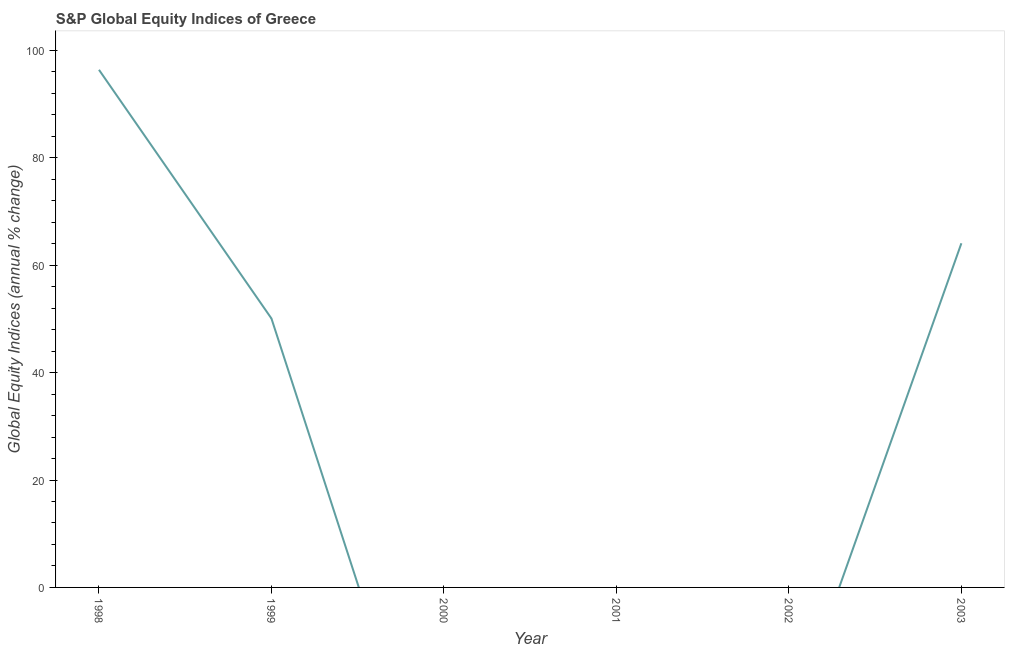What is the s&p global equity indices in 1999?
Give a very brief answer. 50.08. Across all years, what is the maximum s&p global equity indices?
Make the answer very short. 96.39. In which year was the s&p global equity indices maximum?
Offer a terse response. 1998. What is the sum of the s&p global equity indices?
Make the answer very short. 210.56. What is the difference between the s&p global equity indices in 1998 and 2003?
Your answer should be very brief. 32.3. What is the average s&p global equity indices per year?
Your answer should be very brief. 35.09. What is the median s&p global equity indices?
Your answer should be very brief. 25.04. What is the difference between the highest and the second highest s&p global equity indices?
Keep it short and to the point. 32.3. Is the sum of the s&p global equity indices in 1998 and 1999 greater than the maximum s&p global equity indices across all years?
Provide a short and direct response. Yes. What is the difference between the highest and the lowest s&p global equity indices?
Ensure brevity in your answer.  96.39. Does the s&p global equity indices monotonically increase over the years?
Your response must be concise. No. What is the difference between two consecutive major ticks on the Y-axis?
Ensure brevity in your answer.  20. Does the graph contain any zero values?
Offer a very short reply. Yes. What is the title of the graph?
Offer a very short reply. S&P Global Equity Indices of Greece. What is the label or title of the Y-axis?
Offer a very short reply. Global Equity Indices (annual % change). What is the Global Equity Indices (annual % change) in 1998?
Ensure brevity in your answer.  96.39. What is the Global Equity Indices (annual % change) of 1999?
Offer a very short reply. 50.08. What is the Global Equity Indices (annual % change) in 2003?
Your response must be concise. 64.09. What is the difference between the Global Equity Indices (annual % change) in 1998 and 1999?
Your response must be concise. 46.31. What is the difference between the Global Equity Indices (annual % change) in 1998 and 2003?
Your response must be concise. 32.3. What is the difference between the Global Equity Indices (annual % change) in 1999 and 2003?
Make the answer very short. -14.01. What is the ratio of the Global Equity Indices (annual % change) in 1998 to that in 1999?
Offer a very short reply. 1.93. What is the ratio of the Global Equity Indices (annual % change) in 1998 to that in 2003?
Keep it short and to the point. 1.5. What is the ratio of the Global Equity Indices (annual % change) in 1999 to that in 2003?
Offer a terse response. 0.78. 